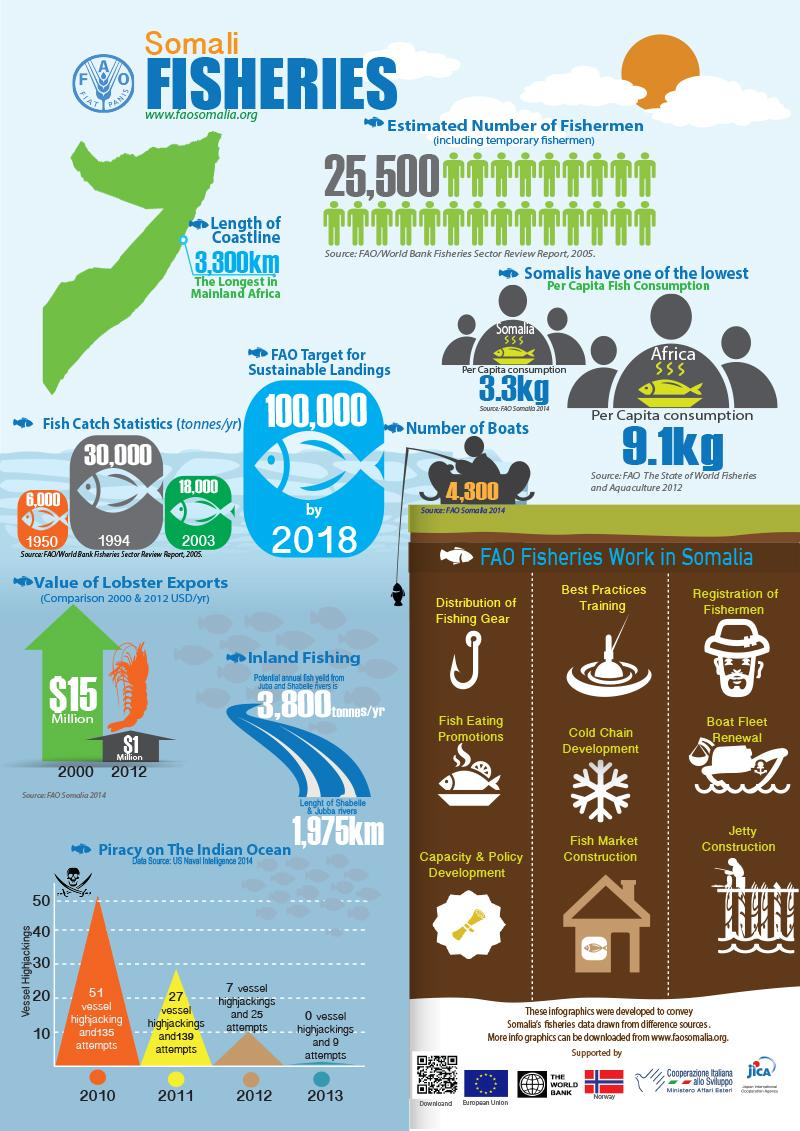List a handful of essential elements in this visual. In 2010, there were 135 reported attempts to hijack vessels off the coast of Somalia, according to the US Naval Intelligence in 2014. In the year 2012, the value of lobster exports from Somalia was estimated to be approximately $1 million. In the year 2000, the value of lobster exports from Somalia was approximately $15 million. As per the FAO Somalia 2014 report, the number of boats in Somalia was approximately 4,300. In 2003, the number of fish catches in Somalia was estimated to be approximately 18,000 tonnes per year. 